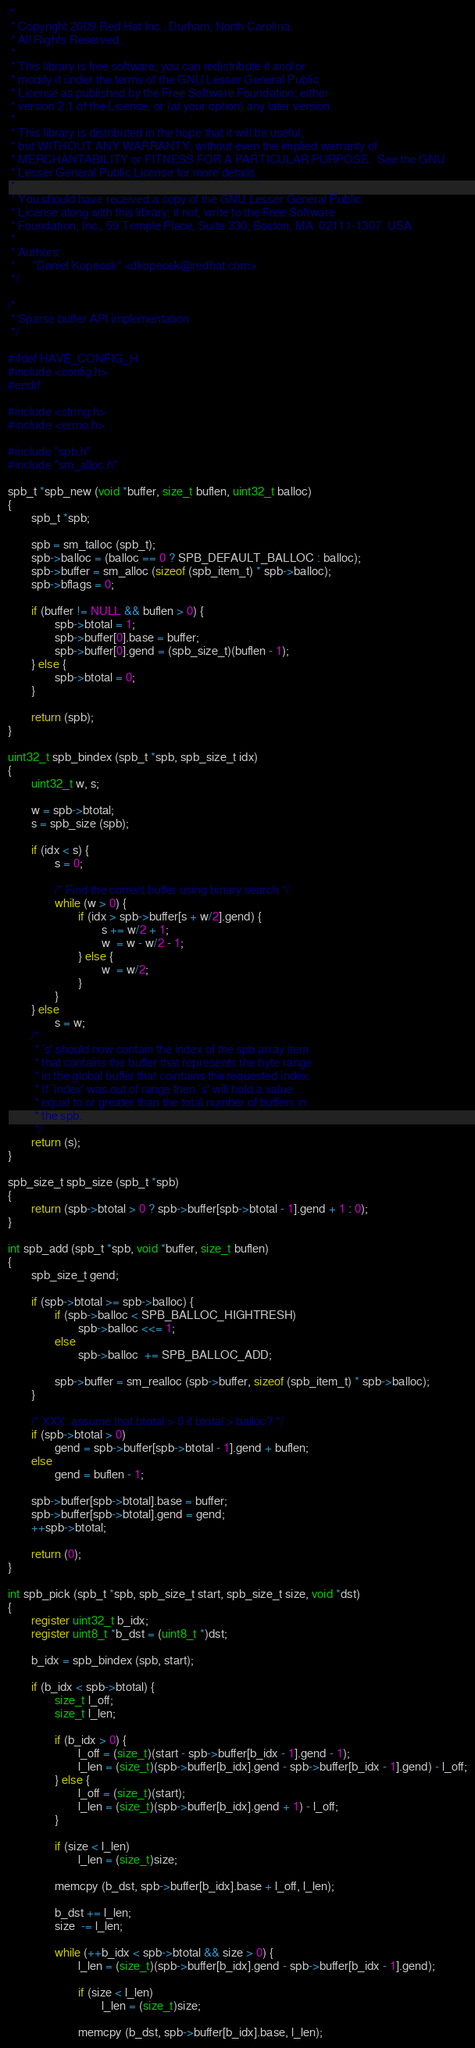<code> <loc_0><loc_0><loc_500><loc_500><_C_>/*
 * Copyright 2009 Red Hat Inc., Durham, North Carolina.
 * All Rights Reserved.
 *
 * This library is free software; you can redistribute it and/or
 * modify it under the terms of the GNU Lesser General Public
 * License as published by the Free Software Foundation; either
 * version 2.1 of the License, or (at your option) any later version.
 *
 * This library is distributed in the hope that it will be useful,
 * but WITHOUT ANY WARRANTY; without even the implied warranty of
 * MERCHANTABILITY or FITNESS FOR A PARTICULAR PURPOSE.  See the GNU
 * Lesser General Public License for more details.
 *
 * You should have received a copy of the GNU Lesser General Public
 * License along with this library; if not, write to the Free Software
 * Foundation, Inc., 59 Temple Place, Suite 330, Boston, MA  02111-1307  USA
 *
 * Authors:
 *      "Daniel Kopecek" <dkopecek@redhat.com>
 */

/*
 * Sparse buffer API implementation
 */

#ifdef HAVE_CONFIG_H
#include <config.h>
#endif

#include <string.h>
#include <errno.h>

#include "spb.h"
#include "sm_alloc.h"

spb_t *spb_new (void *buffer, size_t buflen, uint32_t balloc)
{
        spb_t *spb;

        spb = sm_talloc (spb_t);
        spb->balloc = (balloc == 0 ? SPB_DEFAULT_BALLOC : balloc);
        spb->buffer = sm_alloc (sizeof (spb_item_t) * spb->balloc);
        spb->bflags = 0;

        if (buffer != NULL && buflen > 0) {
                spb->btotal = 1;
                spb->buffer[0].base = buffer;
                spb->buffer[0].gend = (spb_size_t)(buflen - 1);
        } else {
                spb->btotal = 0;
        }

        return (spb);
}

uint32_t spb_bindex (spb_t *spb, spb_size_t idx)
{
        uint32_t w, s;

        w = spb->btotal;
        s = spb_size (spb);

        if (idx < s) {
                s = 0;

                /* Find the correct buffer using binary search */
                while (w > 0) {
                        if (idx > spb->buffer[s + w/2].gend) {
                                s += w/2 + 1;
                                w  = w - w/2 - 1;
                        } else {
                                w  = w/2;
                        }
                }
        } else
                s = w;
        /*
         * `s' should now contain the index of the spb array item
         * that contains the buffer that represents the byte range
         * in the global buffer that cointains the requested index.
         * If `index' was out of range then `s' will hold a value
         * equal to or greater than the total number of buffers in
         * the spb.
         */
        return (s);
}

spb_size_t spb_size (spb_t *spb)
{
        return (spb->btotal > 0 ? spb->buffer[spb->btotal - 1].gend + 1 : 0);
}

int spb_add (spb_t *spb, void *buffer, size_t buflen)
{
        spb_size_t gend;

        if (spb->btotal >= spb->balloc) {
                if (spb->balloc < SPB_BALLOC_HIGHTRESH)
                        spb->balloc <<= 1;
                else
                        spb->balloc  += SPB_BALLOC_ADD;

                spb->buffer = sm_realloc (spb->buffer, sizeof (spb_item_t) * spb->balloc);
        }

        /* XXX: assume that btotal > 0 if btotal > balloc? */
        if (spb->btotal > 0)
                gend = spb->buffer[spb->btotal - 1].gend + buflen;
        else
                gend = buflen - 1;

        spb->buffer[spb->btotal].base = buffer;
        spb->buffer[spb->btotal].gend = gend;
        ++spb->btotal;

        return (0);
}

int spb_pick (spb_t *spb, spb_size_t start, spb_size_t size, void *dst)
{
        register uint32_t b_idx;
        register uint8_t *b_dst = (uint8_t *)dst;

        b_idx = spb_bindex (spb, start);

        if (b_idx < spb->btotal) {
                size_t l_off;
                size_t l_len;

                if (b_idx > 0) {
                        l_off = (size_t)(start - spb->buffer[b_idx - 1].gend - 1);
                        l_len = (size_t)(spb->buffer[b_idx].gend - spb->buffer[b_idx - 1].gend) - l_off;
                } else {
                        l_off = (size_t)(start);
                        l_len = (size_t)(spb->buffer[b_idx].gend + 1) - l_off;
                }

                if (size < l_len)
                        l_len = (size_t)size;

                memcpy (b_dst, spb->buffer[b_idx].base + l_off, l_len);

                b_dst += l_len;
                size  -= l_len;

                while (++b_idx < spb->btotal && size > 0) {
                        l_len = (size_t)(spb->buffer[b_idx].gend - spb->buffer[b_idx - 1].gend);

                        if (size < l_len)
                                l_len = (size_t)size;

                        memcpy (b_dst, spb->buffer[b_idx].base, l_len);
</code> 